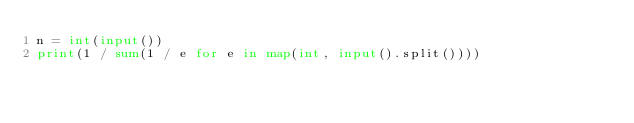Convert code to text. <code><loc_0><loc_0><loc_500><loc_500><_Python_>n = int(input())
print(1 / sum(1 / e for e in map(int, input().split())))</code> 